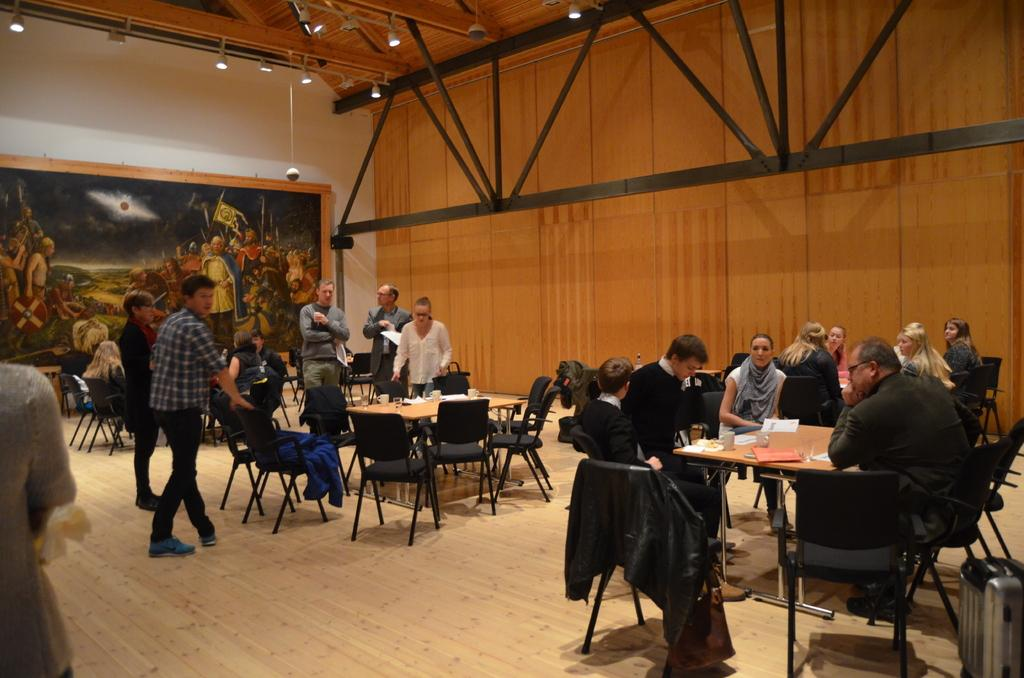What are the people in the image doing? There are people sitting on chairs and standing in the image. What can be seen in the background of the image? There is a wall in the background of the image. What is on the wall in the image? There is a big photo frame on the wall. What type of feather can be seen floating in the air in the image? There is no feather present in the image; it only features people sitting or standing and a wall with a photo frame. 